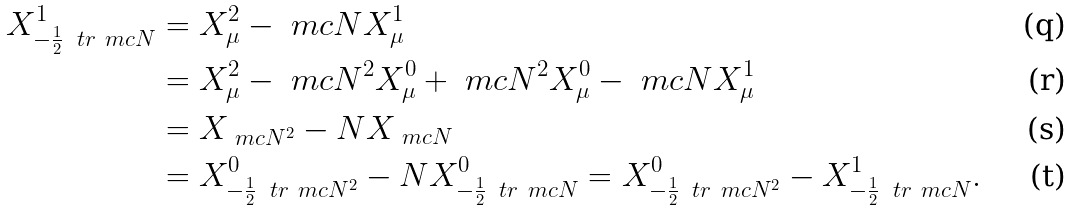<formula> <loc_0><loc_0><loc_500><loc_500>X ^ { 1 } _ { - \frac { 1 } { 2 } \, \ t r \ m c { N } } & = X ^ { 2 } _ { \mu } - \ m c { N } X ^ { 1 } _ { \mu } \\ & = X ^ { 2 } _ { \mu } - \ m c { N } ^ { 2 } X ^ { 0 } _ { \mu } + \ m c { N } ^ { 2 } X ^ { 0 } _ { \mu } - \ m c { N } X ^ { 1 } _ { \mu } \\ & = X _ { \ m c { N } ^ { 2 } } - N X _ { \ m c { N } } \\ & = X ^ { 0 } _ { - \frac { 1 } { 2 } \, \ t r \ m c { N } ^ { 2 } } - N X ^ { 0 } _ { - \frac { 1 } { 2 } \, \ t r \ m c { N } } = X ^ { 0 } _ { - \frac { 1 } { 2 } \, \ t r \ m c { N } ^ { 2 } } - X ^ { 1 } _ { - \frac { 1 } { 2 } \, \ t r \ m c { N } } .</formula> 